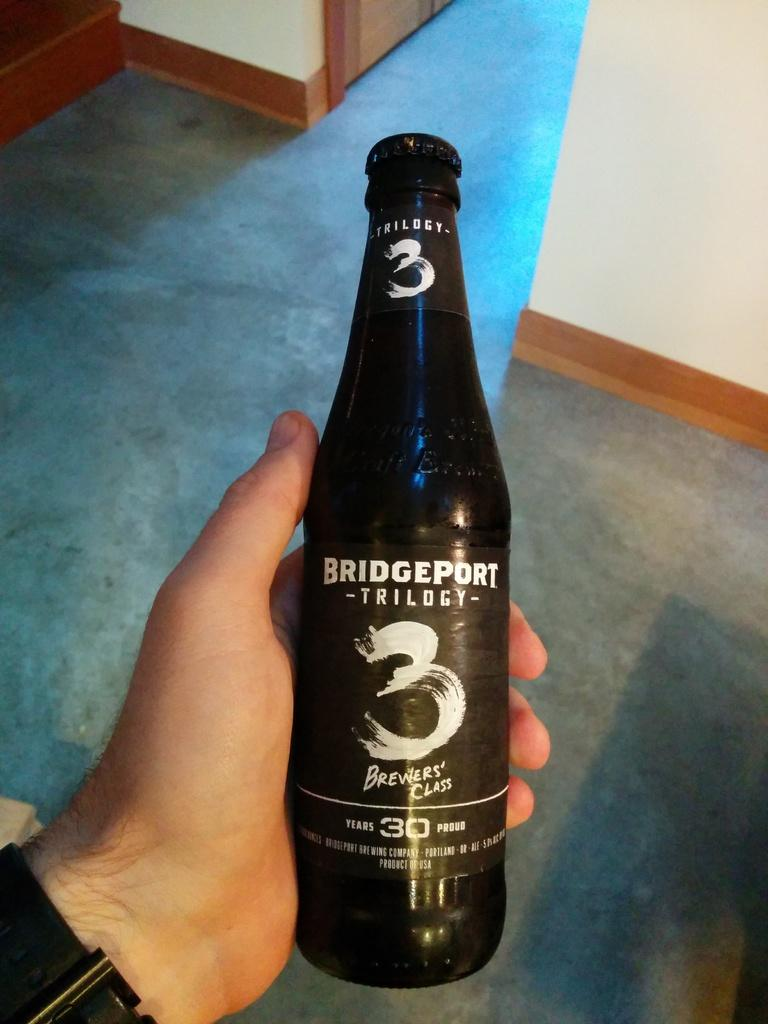<image>
Relay a brief, clear account of the picture shown. A bottle of Bridgeport Brewing Company Trilogy 3 alcoholic beverage. 